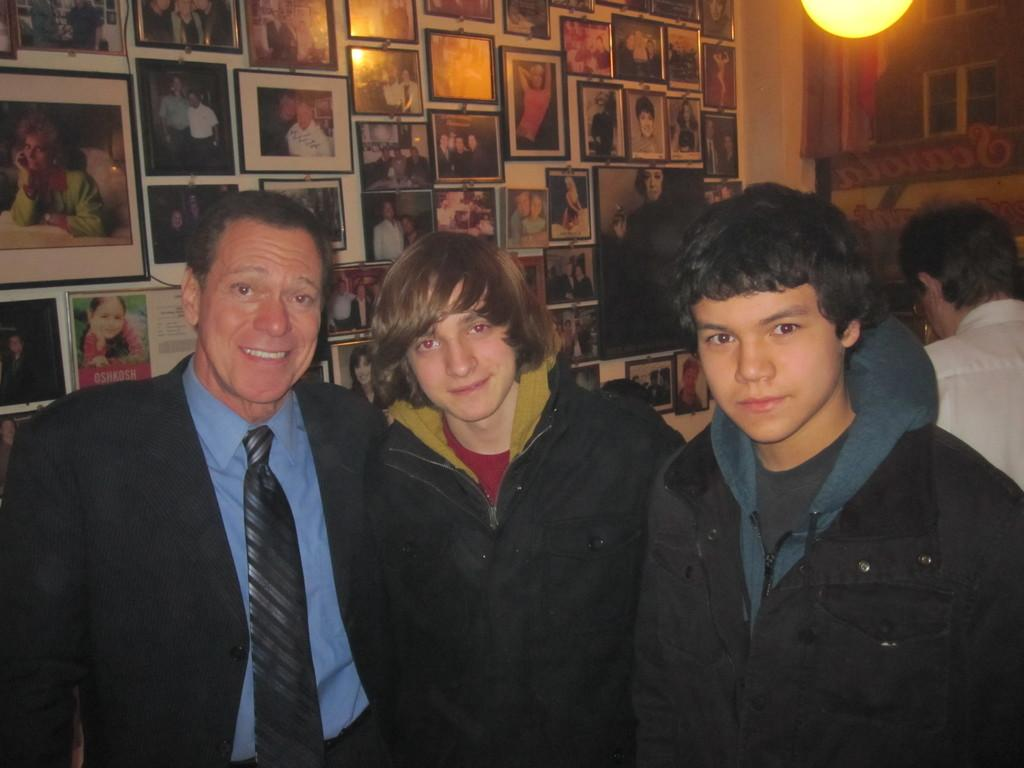How many people are in the image? There is a group of people in the image. What are the people doing in the image? The people are standing on the floor. What can be seen in the background of the image? There is a wall in the background of the image. What is on the wall in the image? The wall has photo frames on it. How many cents are visible on the tray in the image? There is no tray or any currency visible in the image. Is there a bear present in the image? No, there is no bear present in the image. 